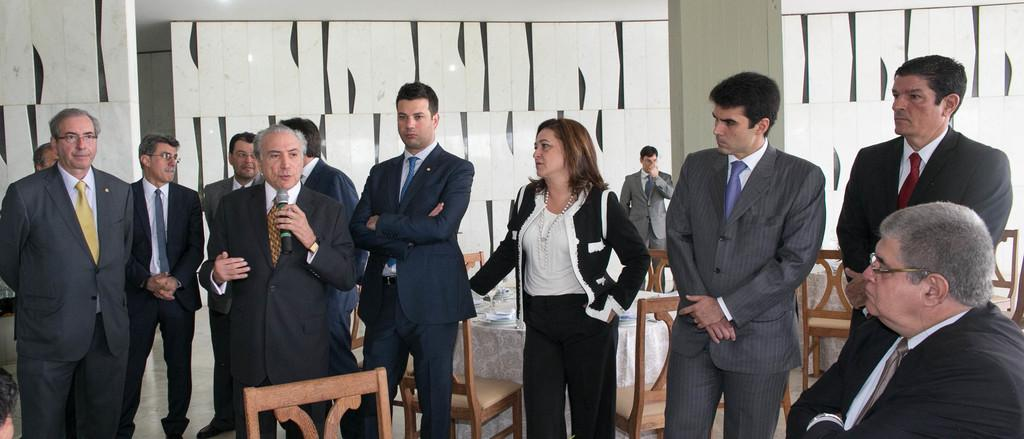What is the main subject of the image? There is a person standing in the center of the image. What is the person in the center doing? The person is talking into a mic. Are there any other people in the image? Yes, there are people standing beside the person with the mic. What can be seen in the background of the image? There is a wall in the background of the image. Are there any objects or furniture in the image? Yes, there are chairs in the image. How many toes does the person's daughter have in the image? There is no mention of a daughter or toes in the image, so it cannot be determined. 